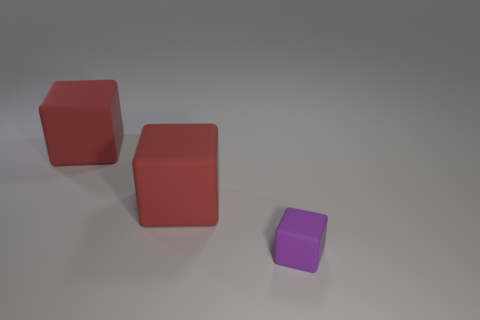Assuming these blocks represent different variables in an experiment, what could the experiment be? If these blocks represented variables, it could be an experiment in physics to study material properties, such as density or friction. Another possibility is a psychological experiment on perception, seeing how people visually group objects or infer relationships between them based on size and color. 